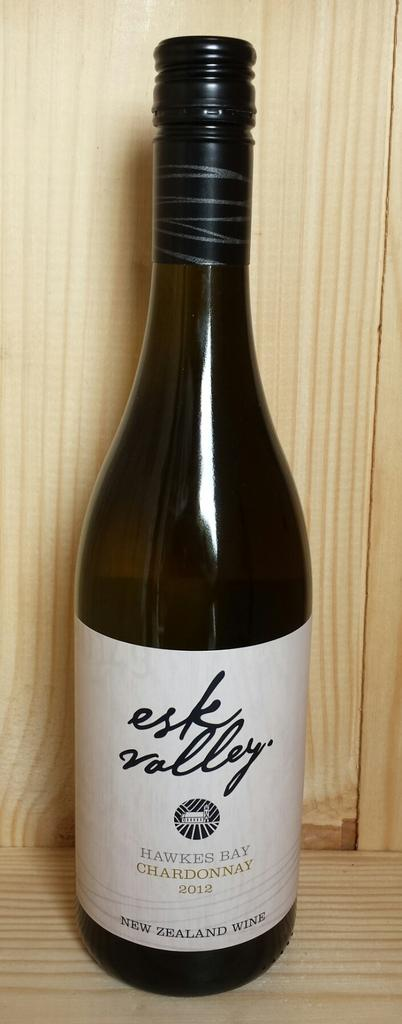<image>
Summarize the visual content of the image. A bottle of Esk Valley Chardonnay sits on a wooden display 